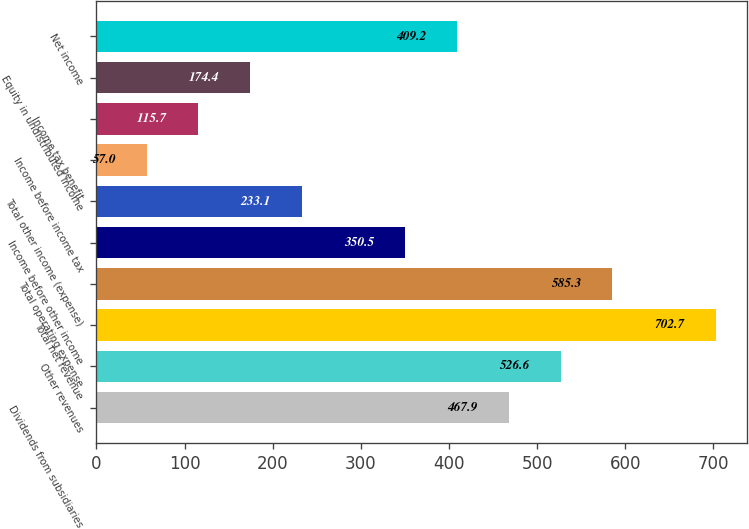Convert chart to OTSL. <chart><loc_0><loc_0><loc_500><loc_500><bar_chart><fcel>Dividends from subsidiaries<fcel>Other revenues<fcel>Total net revenue<fcel>Total operating expense<fcel>Income before other income<fcel>Total other income (expense)<fcel>Income before income tax<fcel>Income tax benefit<fcel>Equity in undistributed income<fcel>Net income<nl><fcel>467.9<fcel>526.6<fcel>702.7<fcel>585.3<fcel>350.5<fcel>233.1<fcel>57<fcel>115.7<fcel>174.4<fcel>409.2<nl></chart> 